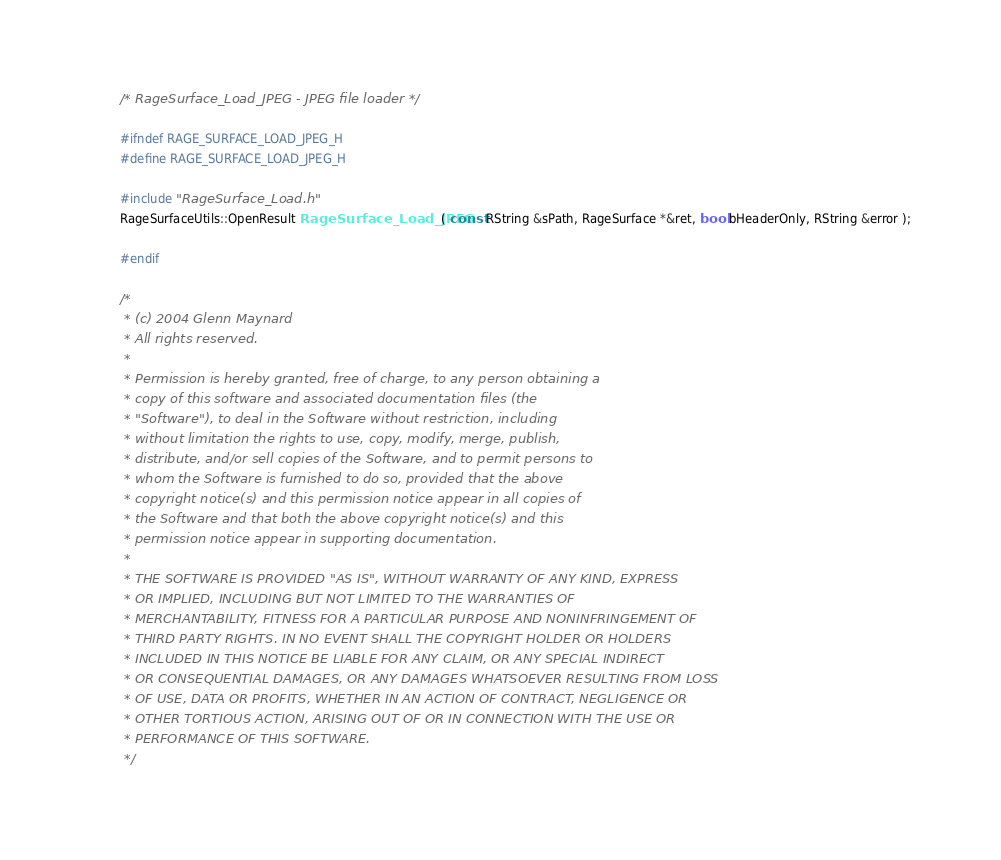<code> <loc_0><loc_0><loc_500><loc_500><_C_>/* RageSurface_Load_JPEG - JPEG file loader */

#ifndef RAGE_SURFACE_LOAD_JPEG_H
#define RAGE_SURFACE_LOAD_JPEG_H

#include "RageSurface_Load.h"
RageSurfaceUtils::OpenResult RageSurface_Load_JPEG( const RString &sPath, RageSurface *&ret, bool bHeaderOnly, RString &error );

#endif

/*
 * (c) 2004 Glenn Maynard
 * All rights reserved.
 * 
 * Permission is hereby granted, free of charge, to any person obtaining a
 * copy of this software and associated documentation files (the
 * "Software"), to deal in the Software without restriction, including
 * without limitation the rights to use, copy, modify, merge, publish,
 * distribute, and/or sell copies of the Software, and to permit persons to
 * whom the Software is furnished to do so, provided that the above
 * copyright notice(s) and this permission notice appear in all copies of
 * the Software and that both the above copyright notice(s) and this
 * permission notice appear in supporting documentation.
 * 
 * THE SOFTWARE IS PROVIDED "AS IS", WITHOUT WARRANTY OF ANY KIND, EXPRESS
 * OR IMPLIED, INCLUDING BUT NOT LIMITED TO THE WARRANTIES OF
 * MERCHANTABILITY, FITNESS FOR A PARTICULAR PURPOSE AND NONINFRINGEMENT OF
 * THIRD PARTY RIGHTS. IN NO EVENT SHALL THE COPYRIGHT HOLDER OR HOLDERS
 * INCLUDED IN THIS NOTICE BE LIABLE FOR ANY CLAIM, OR ANY SPECIAL INDIRECT
 * OR CONSEQUENTIAL DAMAGES, OR ANY DAMAGES WHATSOEVER RESULTING FROM LOSS
 * OF USE, DATA OR PROFITS, WHETHER IN AN ACTION OF CONTRACT, NEGLIGENCE OR
 * OTHER TORTIOUS ACTION, ARISING OUT OF OR IN CONNECTION WITH THE USE OR
 * PERFORMANCE OF THIS SOFTWARE.
 */
</code> 